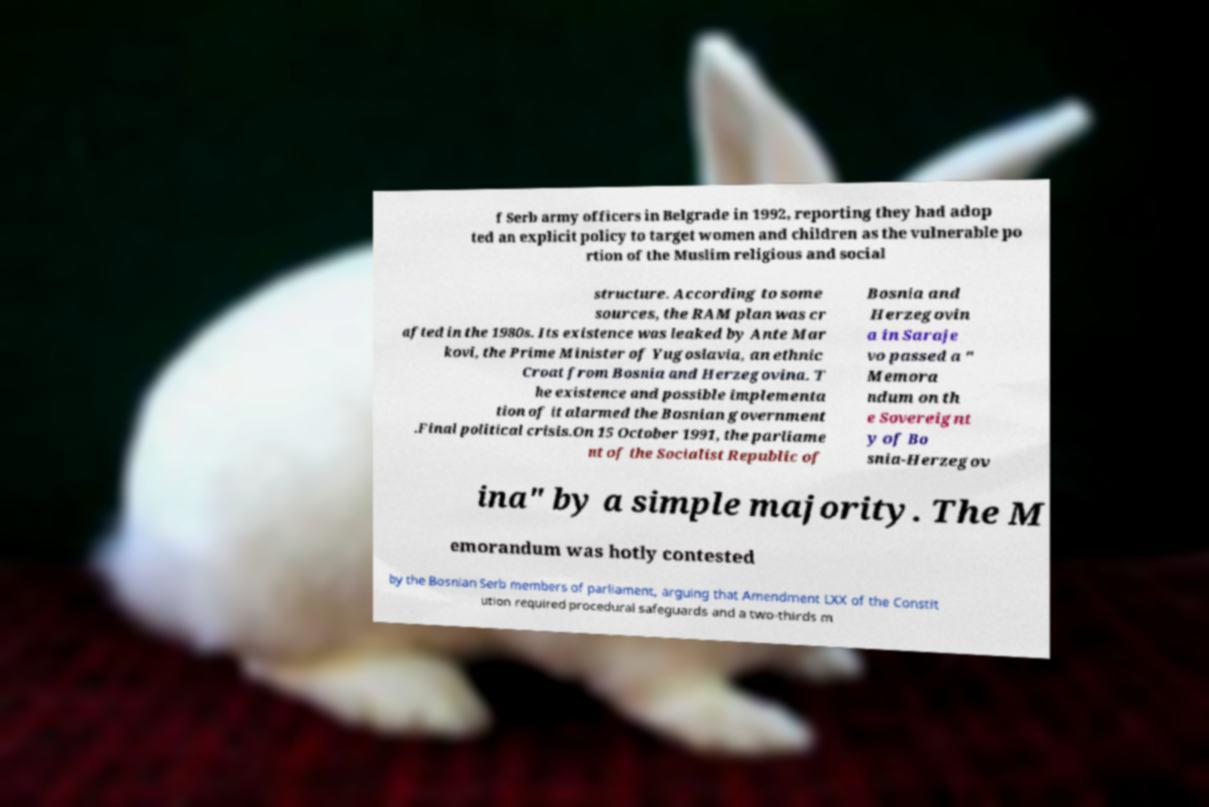For documentation purposes, I need the text within this image transcribed. Could you provide that? f Serb army officers in Belgrade in 1992, reporting they had adop ted an explicit policy to target women and children as the vulnerable po rtion of the Muslim religious and social structure. According to some sources, the RAM plan was cr afted in the 1980s. Its existence was leaked by Ante Mar kovi, the Prime Minister of Yugoslavia, an ethnic Croat from Bosnia and Herzegovina. T he existence and possible implementa tion of it alarmed the Bosnian government .Final political crisis.On 15 October 1991, the parliame nt of the Socialist Republic of Bosnia and Herzegovin a in Saraje vo passed a " Memora ndum on th e Sovereignt y of Bo snia-Herzegov ina" by a simple majority. The M emorandum was hotly contested by the Bosnian Serb members of parliament, arguing that Amendment LXX of the Constit ution required procedural safeguards and a two-thirds m 